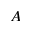Convert formula to latex. <formula><loc_0><loc_0><loc_500><loc_500>A</formula> 